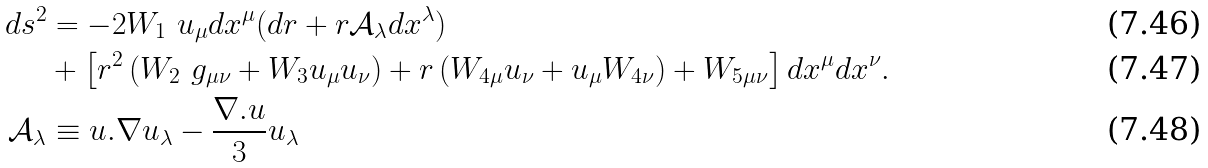Convert formula to latex. <formula><loc_0><loc_0><loc_500><loc_500>d s ^ { 2 } & = - 2 W _ { 1 } \ u _ { \mu } d x ^ { \mu } ( d r + r \mathcal { A } _ { \lambda } d x ^ { \lambda } ) \\ & + \left [ r ^ { 2 } \left ( W _ { 2 } \ g _ { \mu \nu } + W _ { 3 } u _ { \mu } u _ { \nu } \right ) + r \left ( W _ { 4 \mu } u _ { \nu } + u _ { \mu } W _ { 4 \nu } \right ) + W _ { 5 \mu \nu } \right ] d x ^ { \mu } d x ^ { \nu } . \\ \mathcal { A } _ { \lambda } & \equiv u . \nabla u _ { \lambda } - \frac { \nabla . u } { 3 } u _ { \lambda }</formula> 